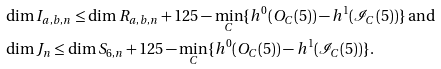<formula> <loc_0><loc_0><loc_500><loc_500>& \dim I _ { a , b , n } \leq \dim R _ { a , b , n } + 1 2 5 - \min _ { C } \{ h ^ { 0 } ( O _ { C } ( 5 ) ) - h ^ { 1 } ( \mathcal { I } _ { C } ( 5 ) ) \} \text { and} \\ & \dim J _ { n } \leq \dim S _ { 6 , n } + 1 2 5 - \min _ { C } \{ h ^ { 0 } ( O _ { C } ( 5 ) ) - h ^ { 1 } ( \mathcal { I } _ { C } ( 5 ) ) \} .</formula> 